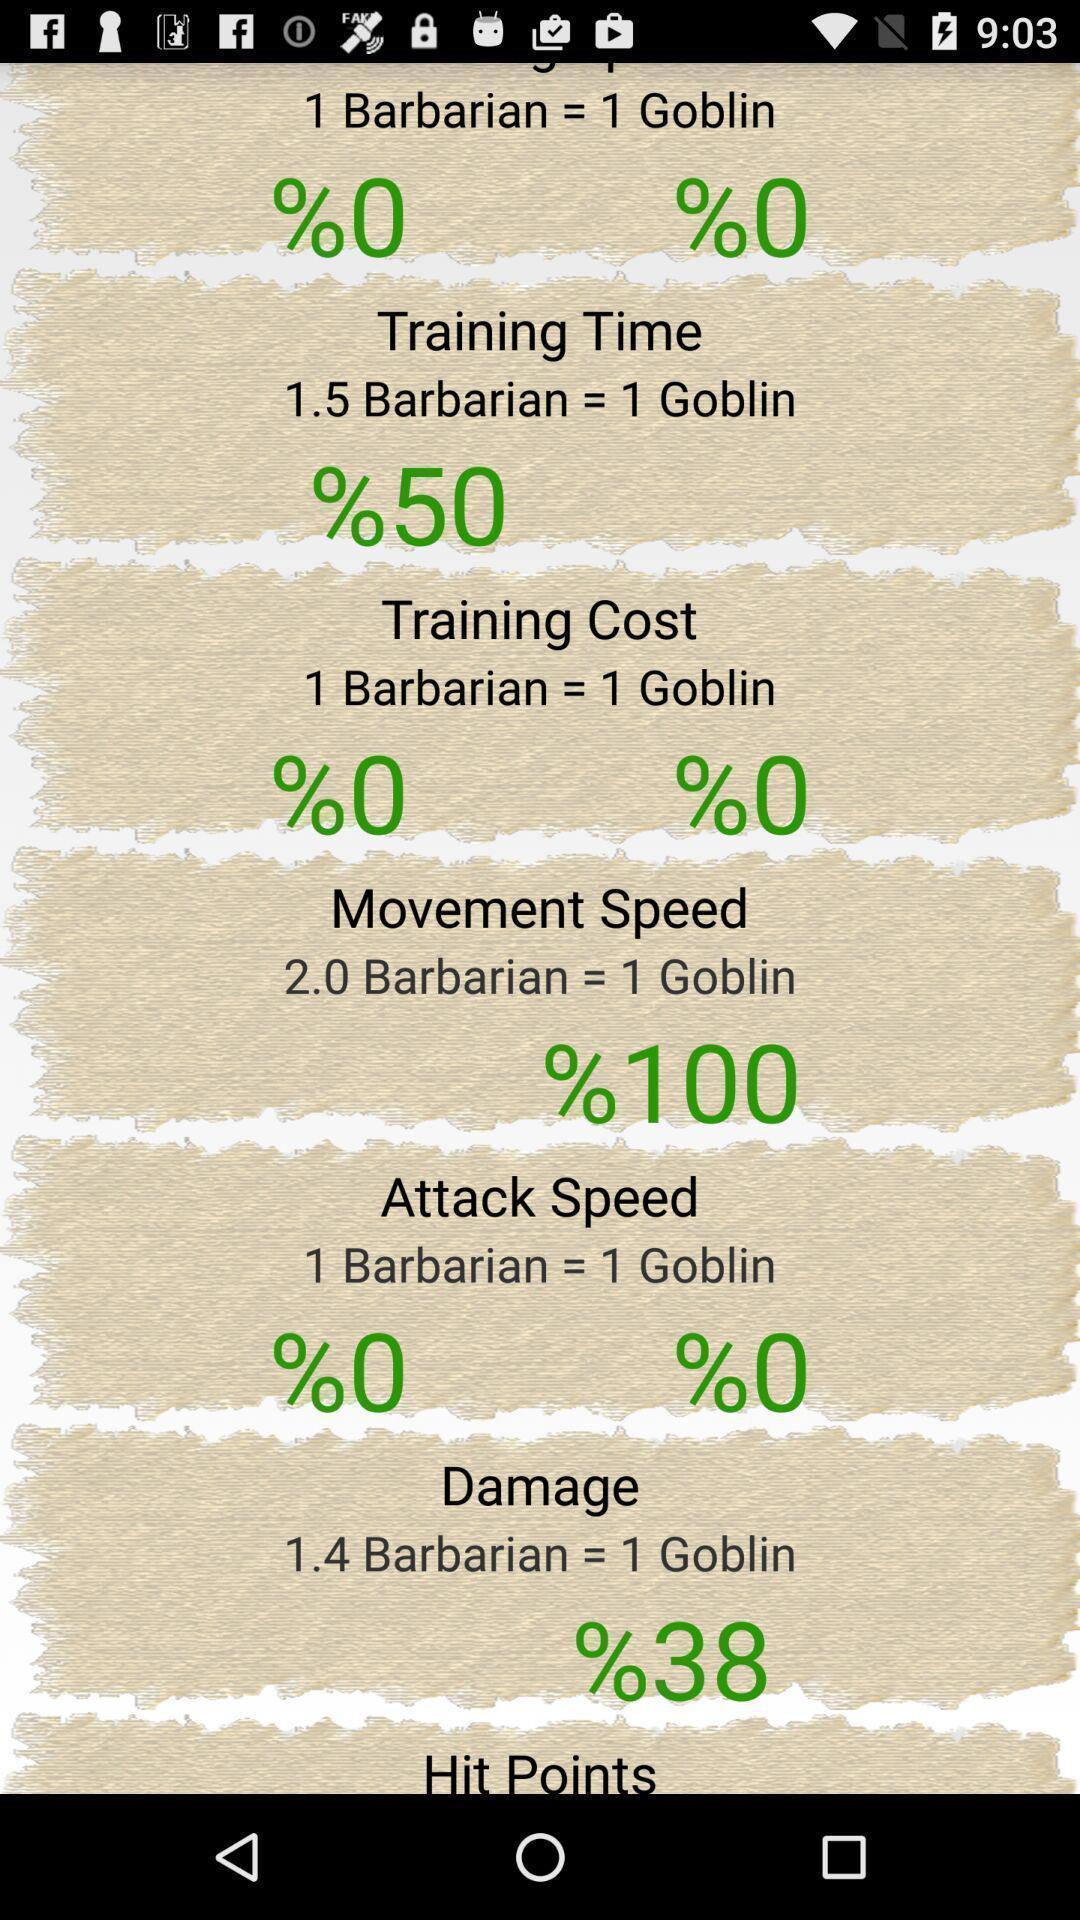Tell me what you see in this picture. Page showing different option in settings. 